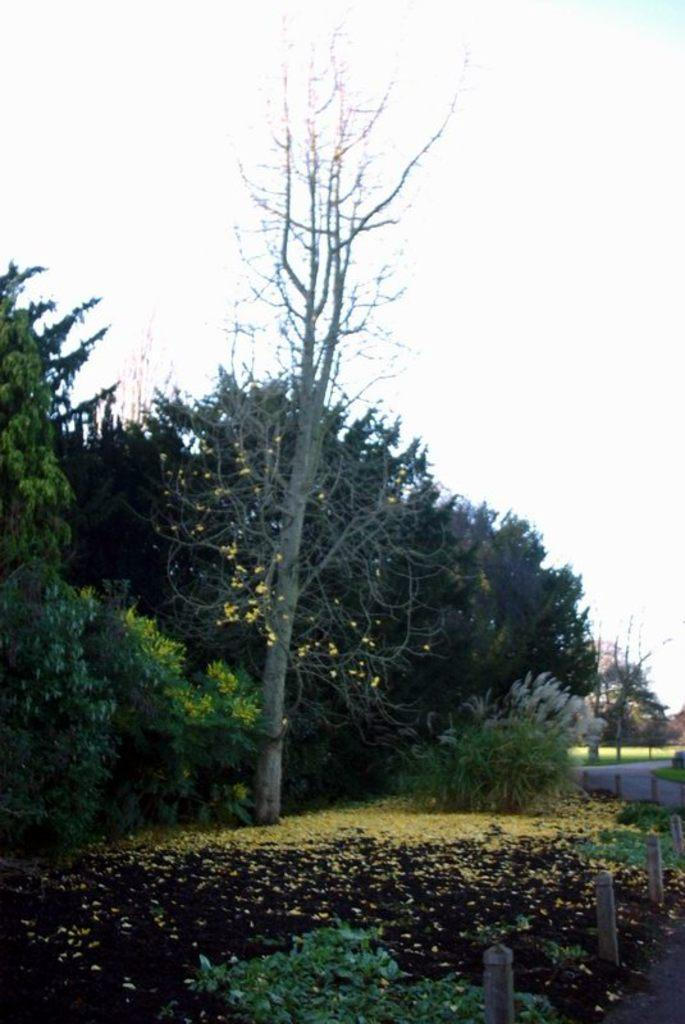What type of vegetation can be seen in the image? There are trees in the image. What can be found on the ground in the image? There are flowers on the ground in the image. What is the purpose of the structure in the image? The fence in the image serves as a boundary or barrier. What type of pathway is visible in the image? There is a road in the image. What type of wrist can be seen in the image? There is no wrist present in the image; it features trees, flowers, a fence, and a road. How does the image convey a sense of disgust? The image does not convey a sense of disgust; it is a neutral representation of the mentioned subjects and objects. 